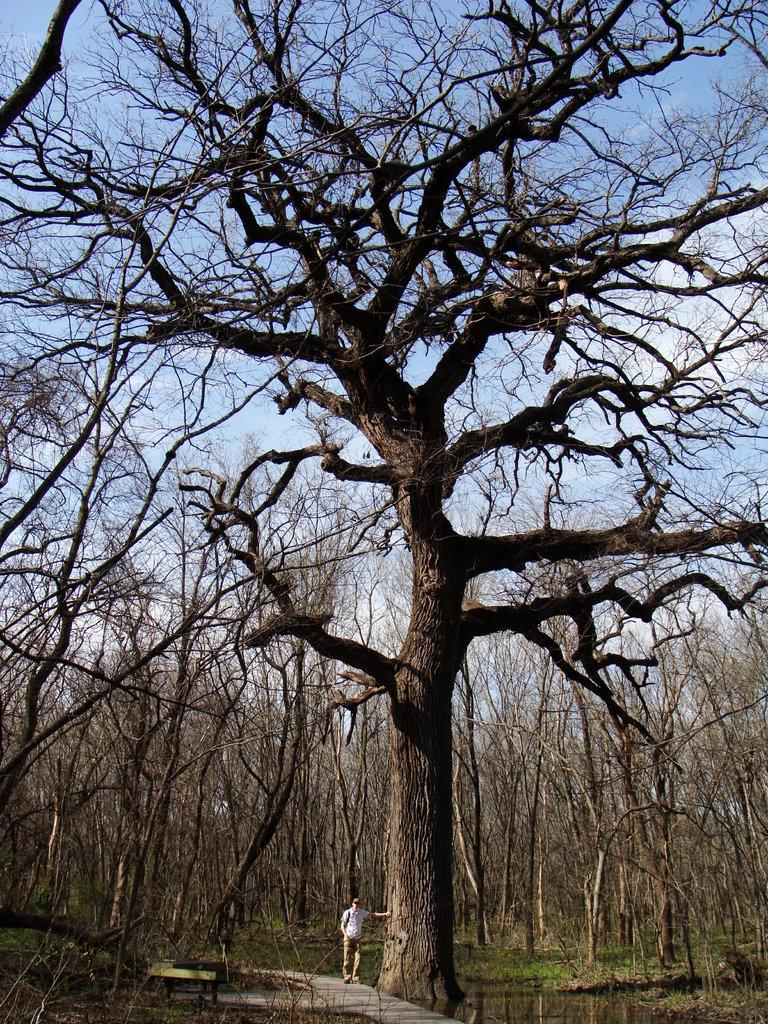What type of vegetation can be seen in the image? There are trees in the image. Can you describe the man's position in the image? There is a man standing near a tree in the image. What can be seen in the background of the image? The sky is visible in the background of the image. What type of kettle is the dad using to make tea for the stranger in the image? There is no dad, stranger, or kettle present in the image. 